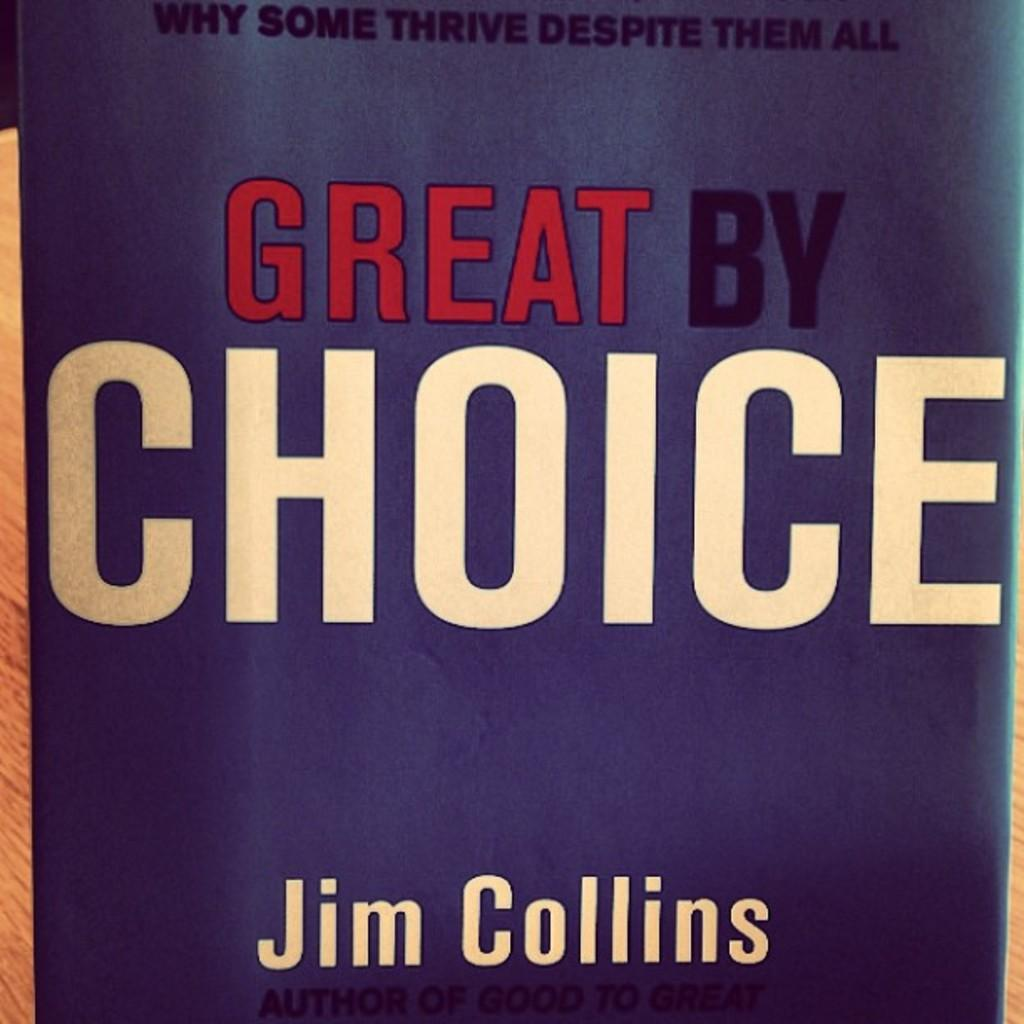<image>
Describe the image concisely. a book in purple that is by Jim Collins 